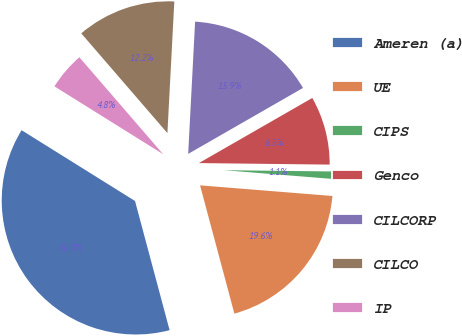Convert chart. <chart><loc_0><loc_0><loc_500><loc_500><pie_chart><fcel>Ameren (a)<fcel>UE<fcel>CIPS<fcel>Genco<fcel>CILCORP<fcel>CILCO<fcel>IP<nl><fcel>38.04%<fcel>19.56%<fcel>1.09%<fcel>8.48%<fcel>15.87%<fcel>12.17%<fcel>4.78%<nl></chart> 